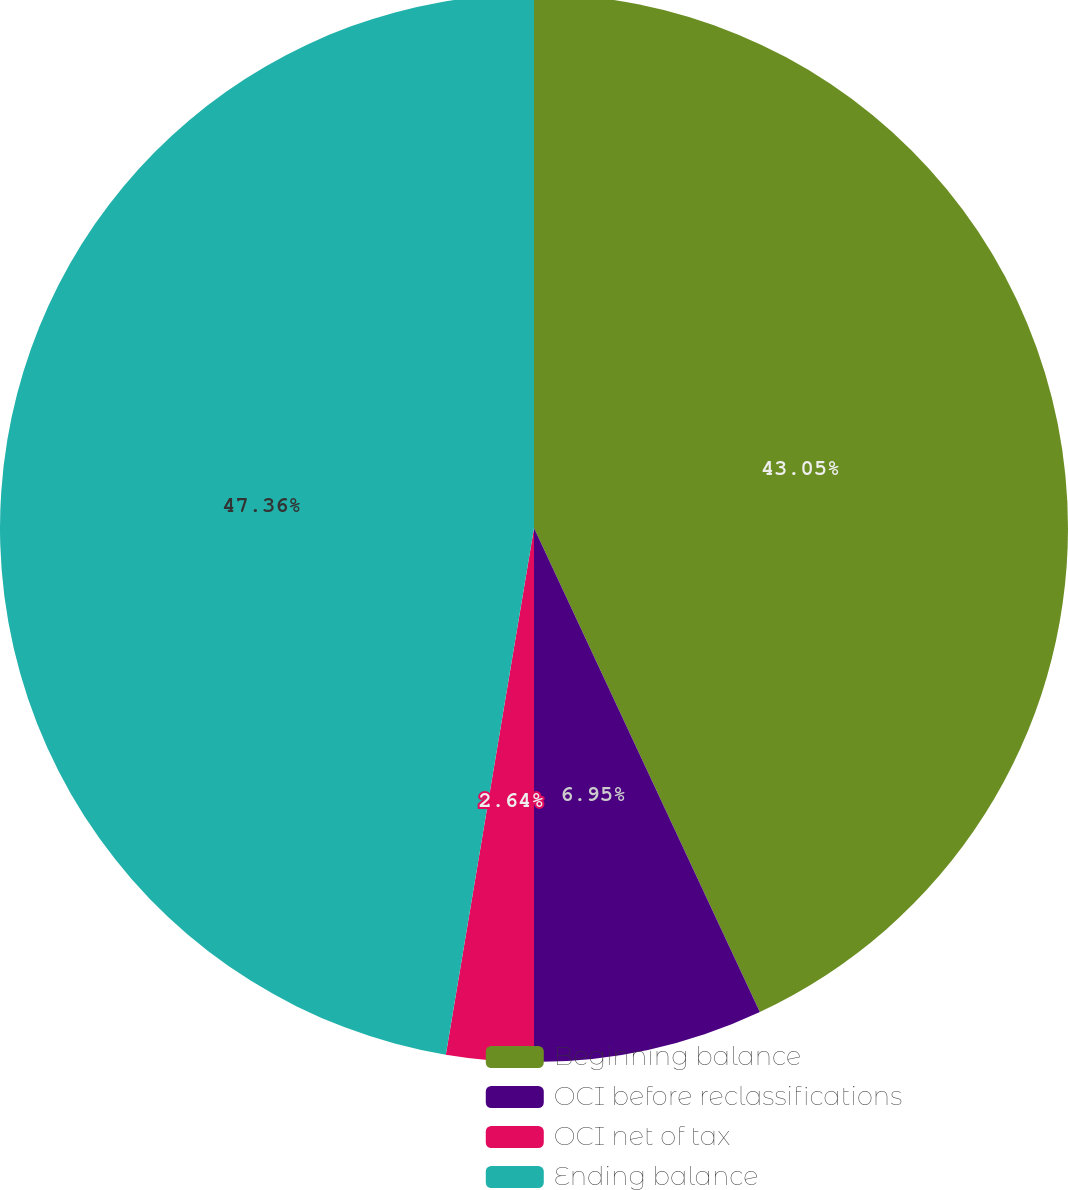Convert chart. <chart><loc_0><loc_0><loc_500><loc_500><pie_chart><fcel>Beginning balance<fcel>OCI before reclassifications<fcel>OCI net of tax<fcel>Ending balance<nl><fcel>43.05%<fcel>6.95%<fcel>2.64%<fcel>47.36%<nl></chart> 